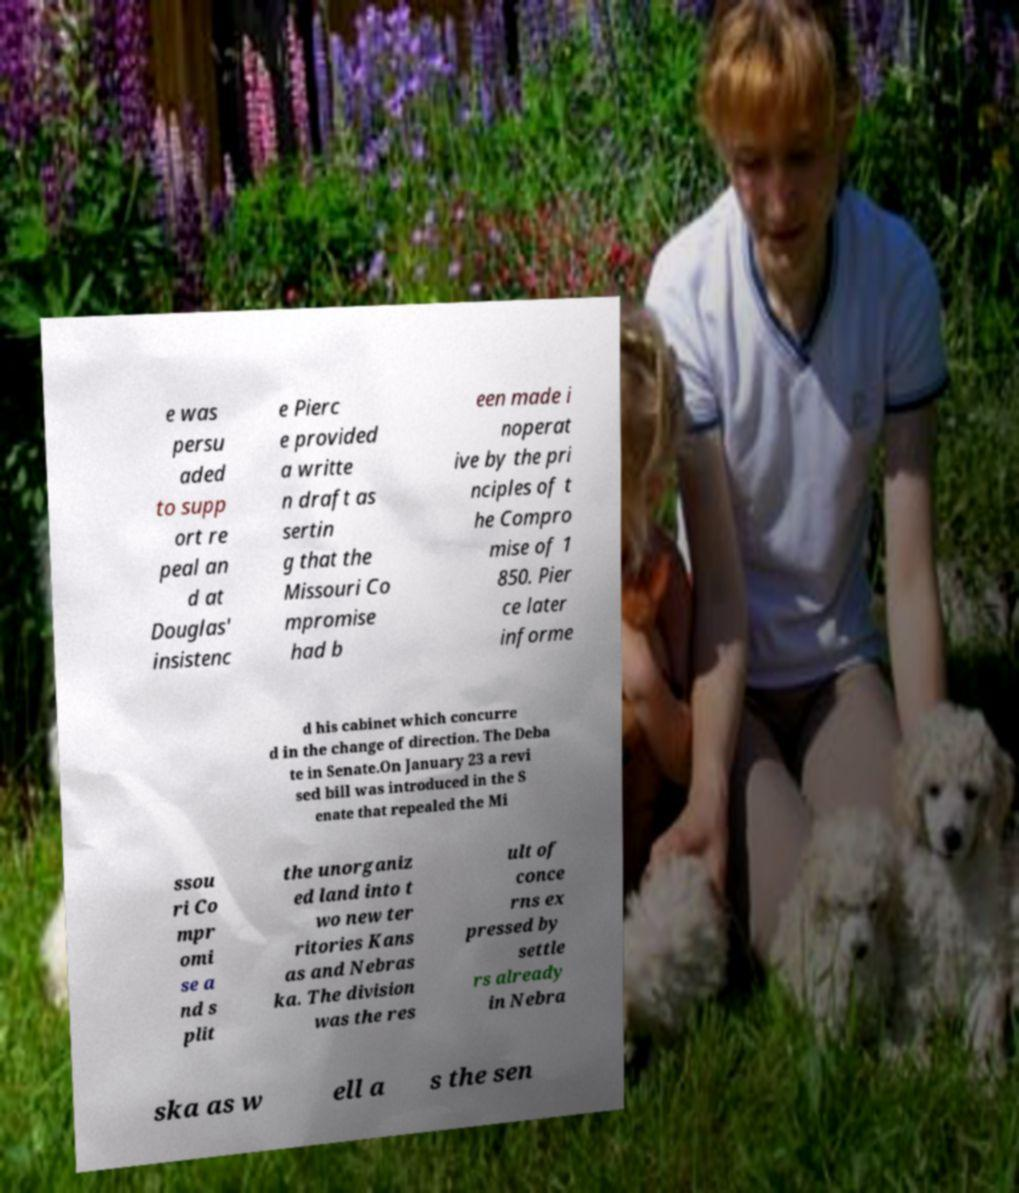What messages or text are displayed in this image? I need them in a readable, typed format. e was persu aded to supp ort re peal an d at Douglas' insistenc e Pierc e provided a writte n draft as sertin g that the Missouri Co mpromise had b een made i noperat ive by the pri nciples of t he Compro mise of 1 850. Pier ce later informe d his cabinet which concurre d in the change of direction. The Deba te in Senate.On January 23 a revi sed bill was introduced in the S enate that repealed the Mi ssou ri Co mpr omi se a nd s plit the unorganiz ed land into t wo new ter ritories Kans as and Nebras ka. The division was the res ult of conce rns ex pressed by settle rs already in Nebra ska as w ell a s the sen 